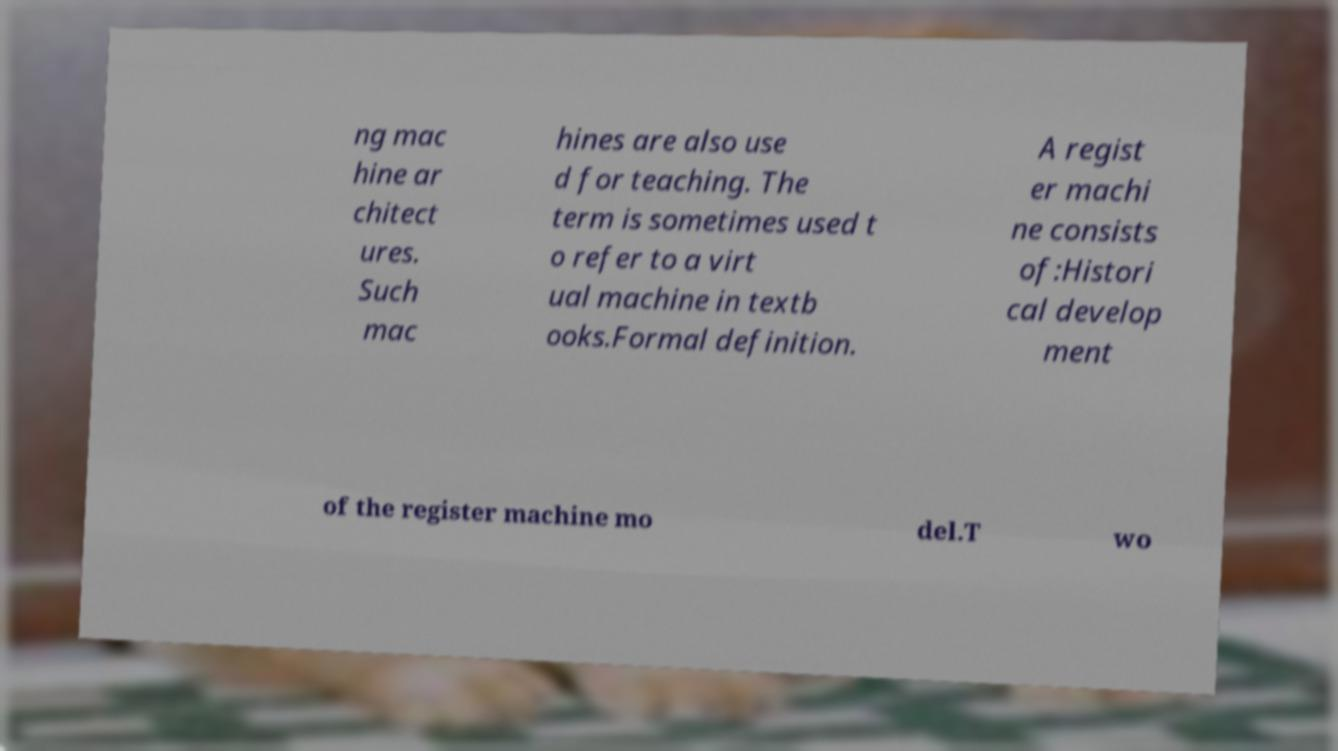Could you assist in decoding the text presented in this image and type it out clearly? ng mac hine ar chitect ures. Such mac hines are also use d for teaching. The term is sometimes used t o refer to a virt ual machine in textb ooks.Formal definition. A regist er machi ne consists of:Histori cal develop ment of the register machine mo del.T wo 